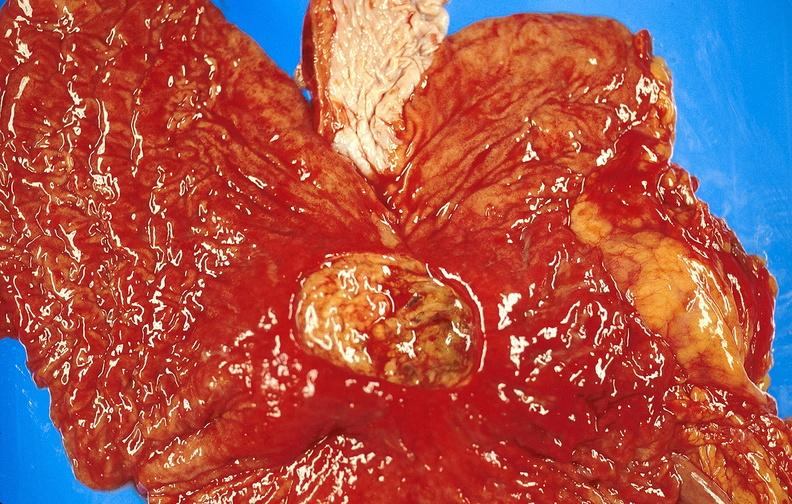what does this image show?
Answer the question using a single word or phrase. Gastric ulcer 